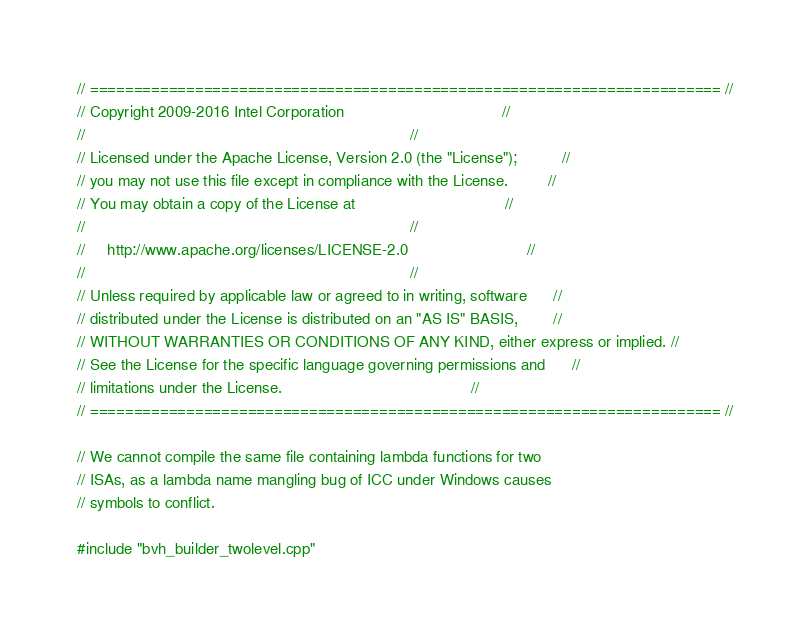<code> <loc_0><loc_0><loc_500><loc_500><_C++_>// ======================================================================== //
// Copyright 2009-2016 Intel Corporation                                    //
//                                                                          //
// Licensed under the Apache License, Version 2.0 (the "License");          //
// you may not use this file except in compliance with the License.         //
// You may obtain a copy of the License at                                  //
//                                                                          //
//     http://www.apache.org/licenses/LICENSE-2.0                           //
//                                                                          //
// Unless required by applicable law or agreed to in writing, software      //
// distributed under the License is distributed on an "AS IS" BASIS,        //
// WITHOUT WARRANTIES OR CONDITIONS OF ANY KIND, either express or implied. //
// See the License for the specific language governing permissions and      //
// limitations under the License.                                           //
// ======================================================================== //

// We cannot compile the same file containing lambda functions for two
// ISAs, as a lambda name mangling bug of ICC under Windows causes
// symbols to conflict.

#include "bvh_builder_twolevel.cpp"

</code> 